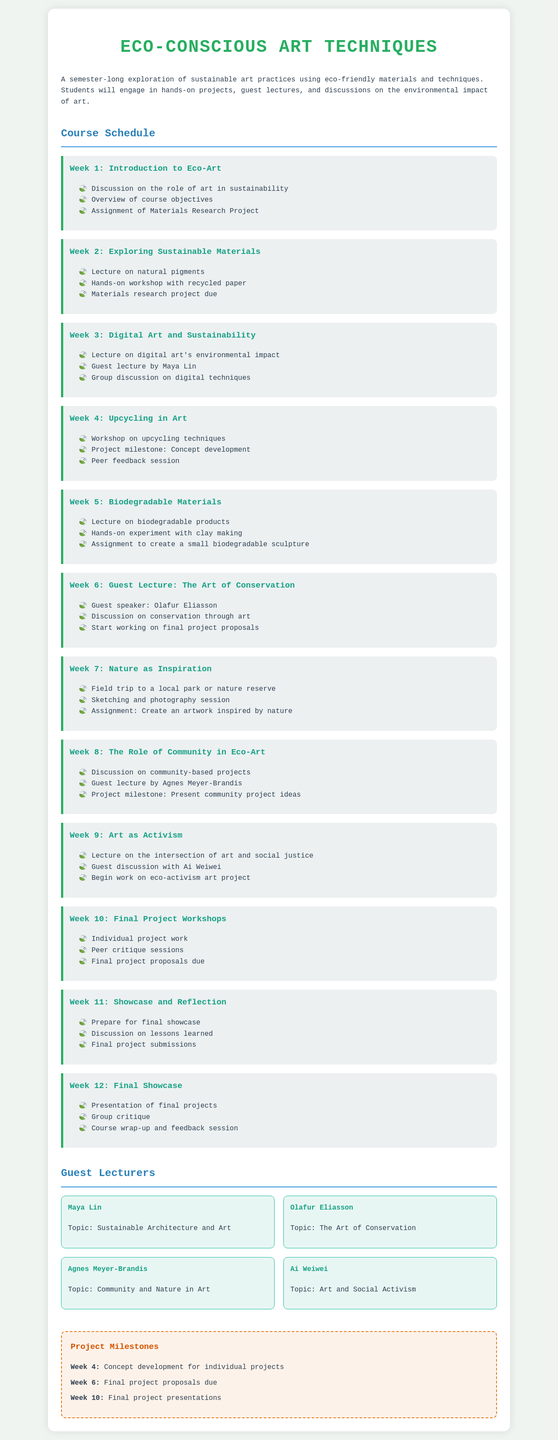What is the title of the course? The title of the course is stated at the top of the document.
Answer: Eco-Conscious Art Techniques Who is the guest lecturer for Week 3? The guest lecturer for Week 3 is mentioned in the activities of that week.
Answer: Maya Lin What is due in Week 2? The due assignment for Week 2 is specified under the activities for that week.
Answer: Materials research project How many weeks are there in the course? The document outlines activities for each week, which can be counted.
Answer: 12 weeks What is the topic of guest lecture by Ai Weiwei? The topic is specified alongside the guest lecturer's name in the guest lecturers section.
Answer: Art and Social Activism Which week focuses on biodegradable materials? The week focusing on biodegradable materials is indicated in the weekly structure.
Answer: Week 5 What is the concept development milestone week? The week when the concept development milestone occurs is highlighted in the milestones section.
Answer: Week 4 What are the final project presentations due? The timing for the final project presentations is noted within the milestones section.
Answer: Week 10 What is the color of the document's background? The color for the document's body background is defined in the styling section.
Answer: Light grey 